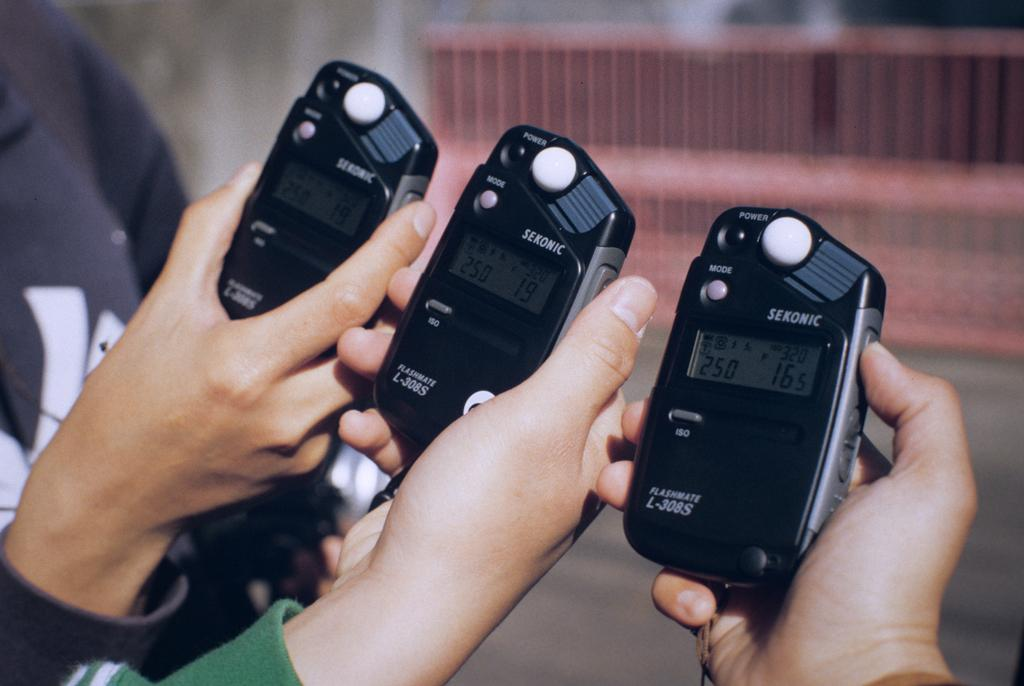What is being held by the hands in the image? Devices are being held by the hands in the image. Can you describe the background of the image? The background of the image is blurry. What type of structure can be seen in the image? There is a fence visible in the image. What type of voice can be heard coming from the devices in the image? There is no indication of sound or voice in the image, as it only shows hands holding devices. 